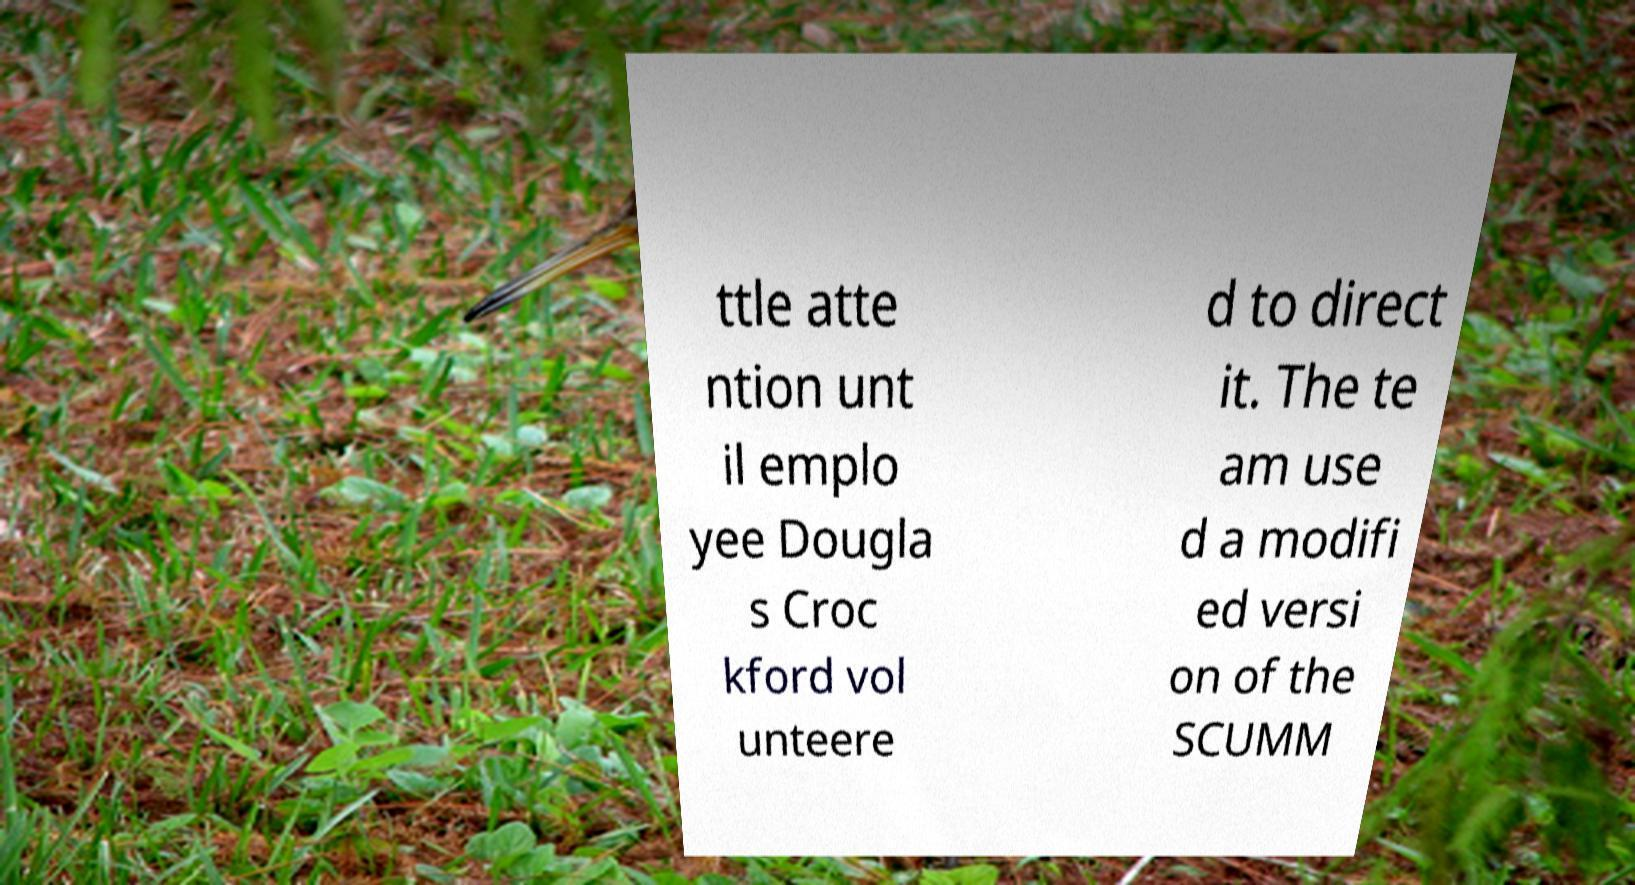Please identify and transcribe the text found in this image. ttle atte ntion unt il emplo yee Dougla s Croc kford vol unteere d to direct it. The te am use d a modifi ed versi on of the SCUMM 